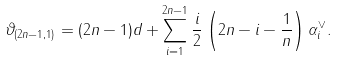<formula> <loc_0><loc_0><loc_500><loc_500>\vartheta _ { ( 2 n - 1 , 1 ) } & = ( 2 n - 1 ) d + \sum _ { i = 1 } ^ { 2 n - 1 } \frac { i } { 2 } \left ( 2 n - i - \frac { 1 } { n } \right ) \alpha ^ { \vee } _ { i } .</formula> 